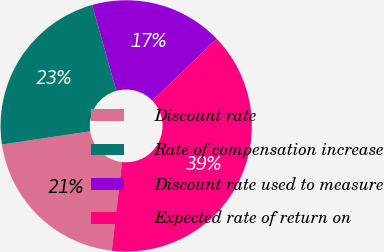Convert chart. <chart><loc_0><loc_0><loc_500><loc_500><pie_chart><fcel>Discount rate<fcel>Rate of compensation increase<fcel>Discount rate used to measure<fcel>Expected rate of return on<nl><fcel>20.81%<fcel>23.0%<fcel>17.17%<fcel>39.02%<nl></chart> 